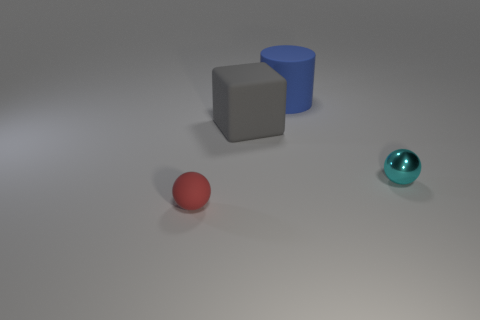Is there anything else that is the same shape as the blue matte thing?
Offer a very short reply. No. What number of matte things are behind the metallic object and left of the big matte cylinder?
Your answer should be compact. 1. How many blue objects are either metal balls or small rubber spheres?
Offer a very short reply. 0. What number of rubber objects are either big objects or purple things?
Provide a short and direct response. 2. Are there any big purple objects?
Your response must be concise. No. Does the large blue thing have the same shape as the cyan metallic thing?
Your answer should be compact. No. There is a tiny ball that is behind the small ball to the left of the metal sphere; how many matte objects are in front of it?
Offer a very short reply. 1. What is the material of the object that is both in front of the big gray rubber object and to the right of the large block?
Ensure brevity in your answer.  Metal. The thing that is both right of the big gray thing and behind the cyan metal object is what color?
Ensure brevity in your answer.  Blue. Is there anything else of the same color as the shiny ball?
Make the answer very short. No. 